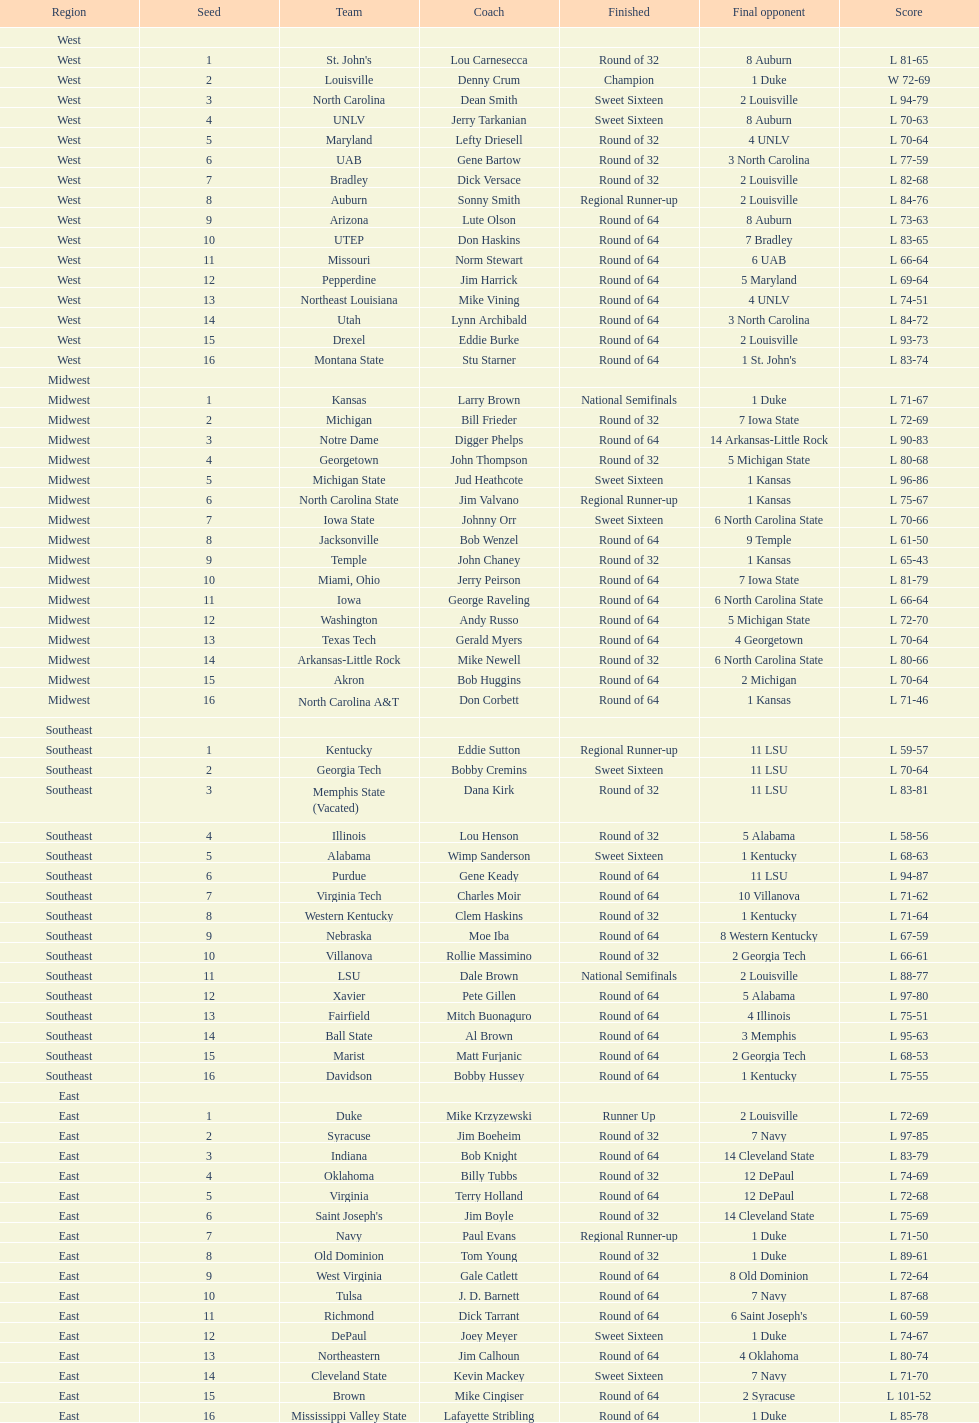Which area is mentioned prior to the midwest? West. 